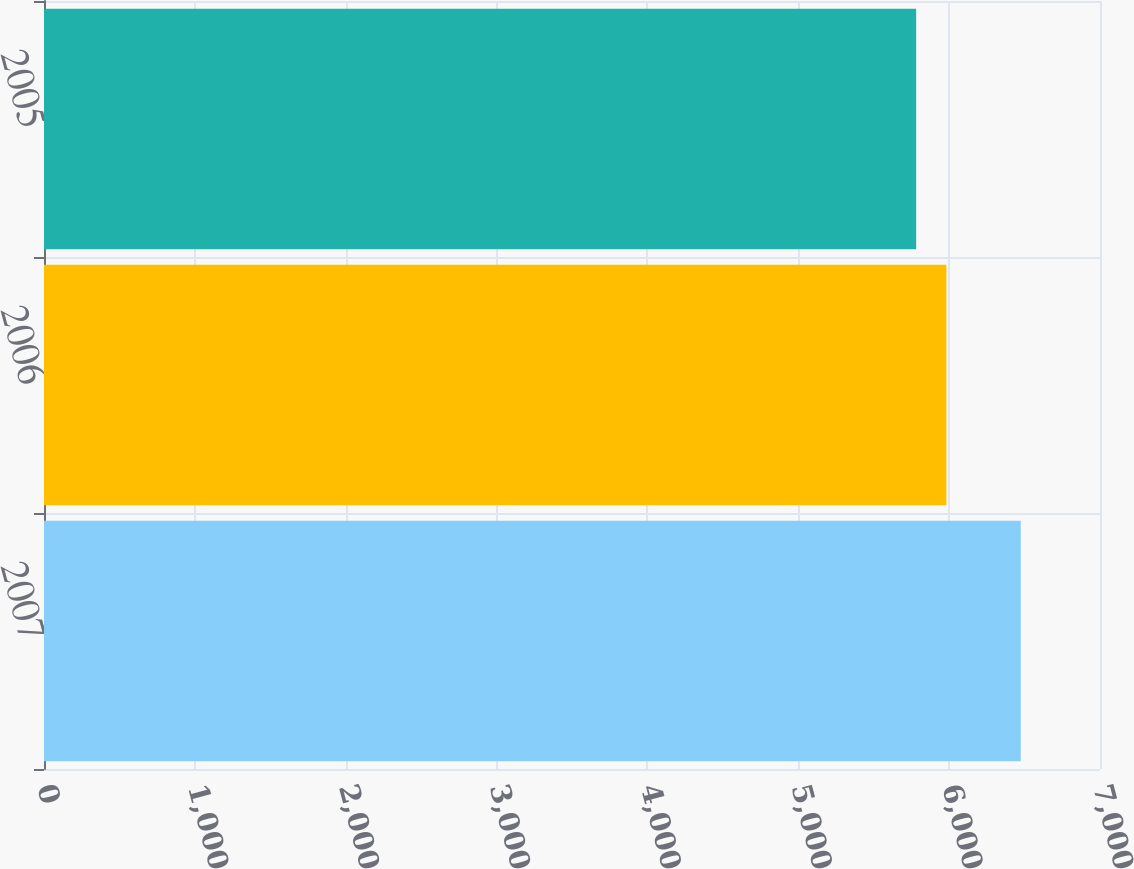Convert chart. <chart><loc_0><loc_0><loc_500><loc_500><bar_chart><fcel>2007<fcel>2006<fcel>2005<nl><fcel>6474.5<fcel>5982<fcel>5781.3<nl></chart> 